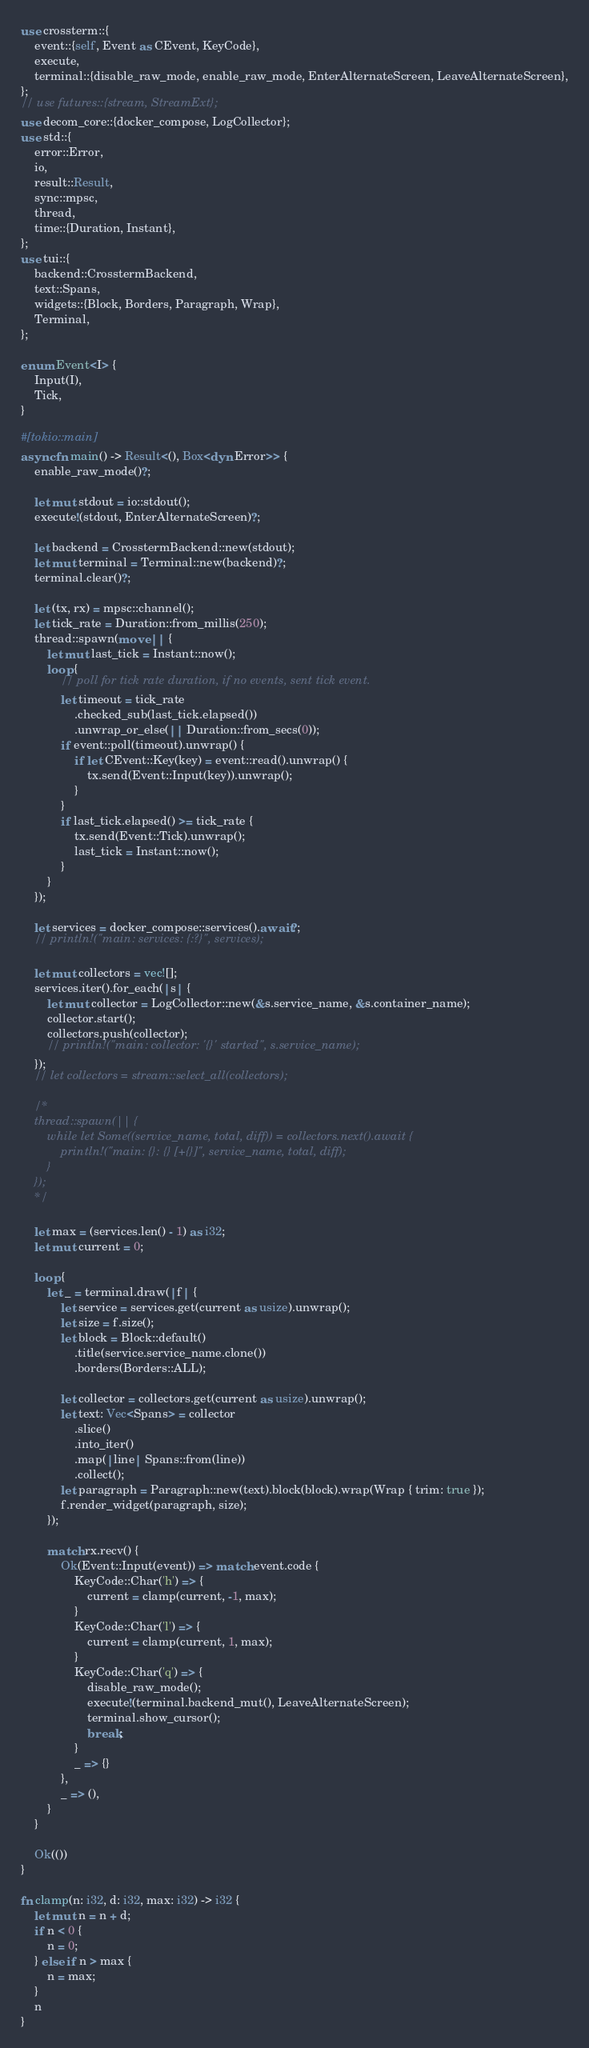Convert code to text. <code><loc_0><loc_0><loc_500><loc_500><_Rust_>use crossterm::{
    event::{self, Event as CEvent, KeyCode},
    execute,
    terminal::{disable_raw_mode, enable_raw_mode, EnterAlternateScreen, LeaveAlternateScreen},
};
// use futures::{stream, StreamExt};
use decom_core::{docker_compose, LogCollector};
use std::{
    error::Error,
    io,
    result::Result,
    sync::mpsc,
    thread,
    time::{Duration, Instant},
};
use tui::{
    backend::CrosstermBackend,
    text::Spans,
    widgets::{Block, Borders, Paragraph, Wrap},
    Terminal,
};

enum Event<I> {
    Input(I),
    Tick,
}

#[tokio::main]
async fn main() -> Result<(), Box<dyn Error>> {
    enable_raw_mode()?;

    let mut stdout = io::stdout();
    execute!(stdout, EnterAlternateScreen)?;

    let backend = CrosstermBackend::new(stdout);
    let mut terminal = Terminal::new(backend)?;
    terminal.clear()?;

    let (tx, rx) = mpsc::channel();
    let tick_rate = Duration::from_millis(250);
    thread::spawn(move || {
        let mut last_tick = Instant::now();
        loop {
            // poll for tick rate duration, if no events, sent tick event.
            let timeout = tick_rate
                .checked_sub(last_tick.elapsed())
                .unwrap_or_else(|| Duration::from_secs(0));
            if event::poll(timeout).unwrap() {
                if let CEvent::Key(key) = event::read().unwrap() {
                    tx.send(Event::Input(key)).unwrap();
                }
            }
            if last_tick.elapsed() >= tick_rate {
                tx.send(Event::Tick).unwrap();
                last_tick = Instant::now();
            }
        }
    });

    let services = docker_compose::services().await?;
    // println!("main: services: {:?}", services);

    let mut collectors = vec![];
    services.iter().for_each(|s| {
        let mut collector = LogCollector::new(&s.service_name, &s.container_name);
        collector.start();
        collectors.push(collector);
        // println!("main: collector: '{}' started", s.service_name);
    });
    // let collectors = stream::select_all(collectors);

    /*
    thread::spawn(|| {
        while let Some((service_name, total, diff)) = collectors.next().await {
            println!("main: {}: {} [+{}]", service_name, total, diff);
        }
    });
    */

    let max = (services.len() - 1) as i32;
    let mut current = 0;

    loop {
        let _ = terminal.draw(|f| {
            let service = services.get(current as usize).unwrap();
            let size = f.size();
            let block = Block::default()
                .title(service.service_name.clone())
                .borders(Borders::ALL);

            let collector = collectors.get(current as usize).unwrap();
            let text: Vec<Spans> = collector
                .slice()
                .into_iter()
                .map(|line| Spans::from(line))
                .collect();
            let paragraph = Paragraph::new(text).block(block).wrap(Wrap { trim: true });
            f.render_widget(paragraph, size);
        });

        match rx.recv() {
            Ok(Event::Input(event)) => match event.code {
                KeyCode::Char('h') => {
                    current = clamp(current, -1, max);
                }
                KeyCode::Char('l') => {
                    current = clamp(current, 1, max);
                }
                KeyCode::Char('q') => {
                    disable_raw_mode();
                    execute!(terminal.backend_mut(), LeaveAlternateScreen);
                    terminal.show_cursor();
                    break;
                }
                _ => {}
            },
            _ => (),
        }
    }

    Ok(())
}

fn clamp(n: i32, d: i32, max: i32) -> i32 {
    let mut n = n + d;
    if n < 0 {
        n = 0;
    } else if n > max {
        n = max;
    }
    n
}
</code> 